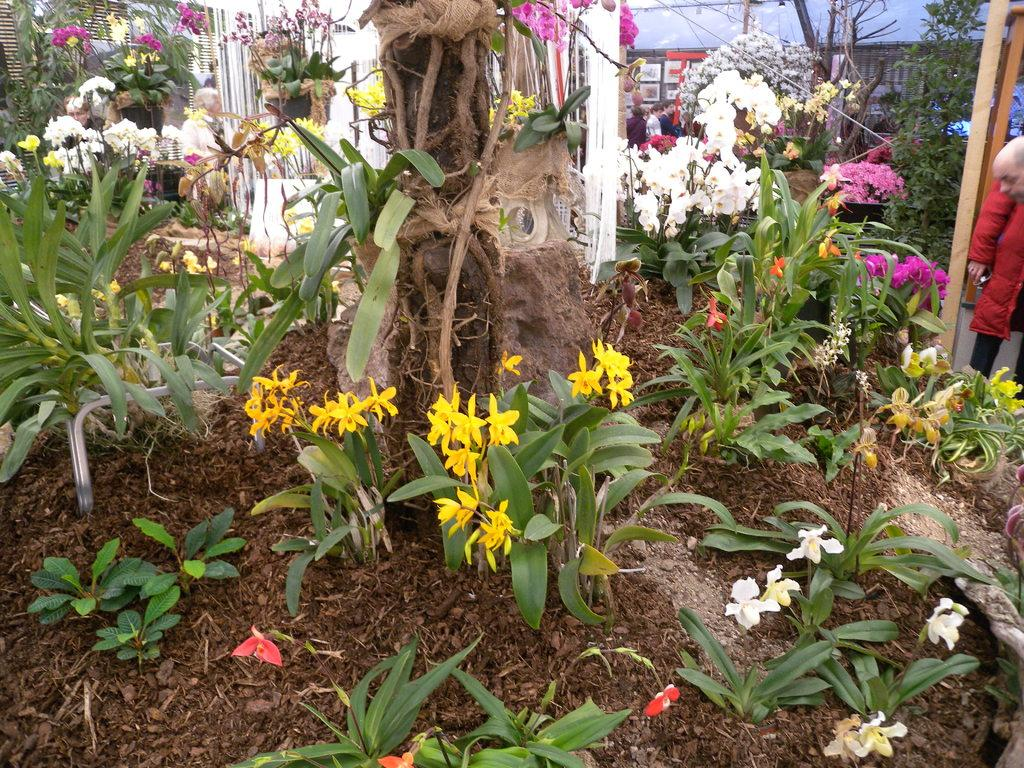What type of setting is depicted in the image? The image appears to depict a nursery. What kind of decorative elements can be seen in the image? There are beautiful plants in the image. Are there any people present in the image? Yes, there are people present among the plants. What type of tail can be seen on the plants in the image? There are no tails present on the plants in the image. Are there any trains visible among the plants in the image? No, there are no trains visible in the image. 